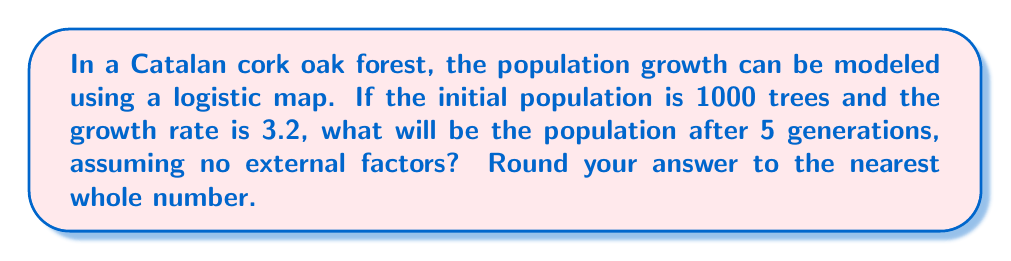Can you answer this question? To solve this problem, we'll use the logistic map equation and iterate it for 5 generations:

1) The logistic map equation is:
   $$x_{n+1} = rx_n(1-x_n)$$
   where $r$ is the growth rate and $x_n$ is the population at generation $n$.

2) We need to normalize the initial population to a value between 0 and 1:
   $$x_0 = 1000/10000 = 0.1$$ (assuming 10000 is the maximum population)

3) Now, let's iterate for 5 generations:

   Generation 1: $x_1 = 3.2 * 0.1 * (1-0.1) = 0.288$
   Generation 2: $x_2 = 3.2 * 0.288 * (1-0.288) \approx 0.656$
   Generation 3: $x_3 = 3.2 * 0.656 * (1-0.656) \approx 0.722$
   Generation 4: $x_4 = 3.2 * 0.722 * (1-0.722) \approx 0.642$
   Generation 5: $x_5 = 3.2 * 0.642 * (1-0.642) \approx 0.735$

4) To get the actual population, we multiply by 10000:
   $$0.735 * 10000 = 7350$$

5) Rounding to the nearest whole number: 7350
Answer: 7350 